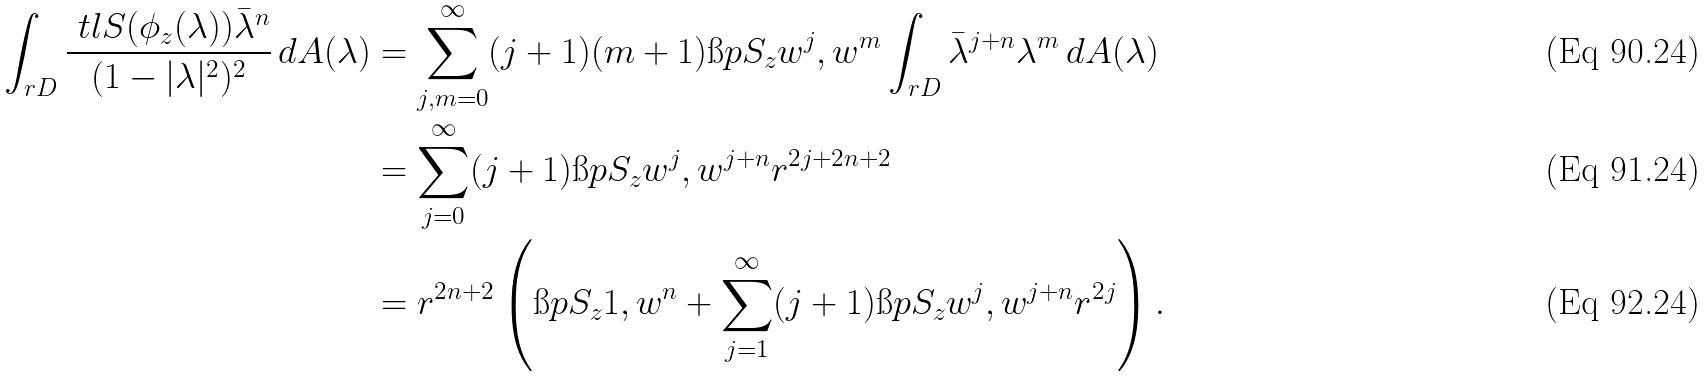<formula> <loc_0><loc_0><loc_500><loc_500>\int _ { r D } \frac { \ t l { S } ( \phi _ { z } ( \lambda ) ) \bar { \lambda } ^ { n } } { ( 1 - | \lambda | ^ { 2 } ) ^ { 2 } } \, d A ( \lambda ) & = \sum _ { j , m = 0 } ^ { \infty } ( j + 1 ) ( m + 1 ) \i p { S _ { z } w ^ { j } , w ^ { m } } \int _ { r D } \bar { \lambda } ^ { j + n } \lambda ^ { m } \, d A ( \lambda ) \\ & = \sum _ { j = 0 } ^ { \infty } ( j + 1 ) \i p { S _ { z } w ^ { j } , w ^ { j + n } } r ^ { 2 j + 2 n + 2 } \\ & = r ^ { 2 n + 2 } \left ( \i p { S _ { z } 1 , w ^ { n } } + \sum _ { j = 1 } ^ { \infty } ( j + 1 ) \i p { S _ { z } w ^ { j } , w ^ { j + n } } r ^ { 2 j } \right ) .</formula> 